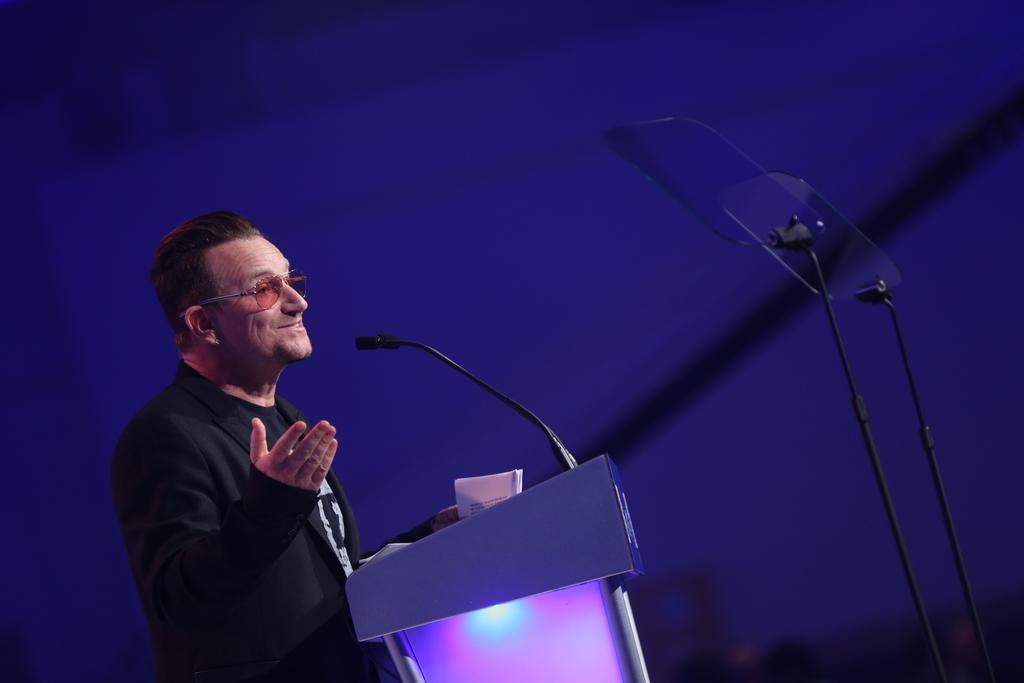Please provide a concise description of this image. In this picture I can see a man standing at a podium and I can see a microphone and couple of stands on the right side and a dark background. 